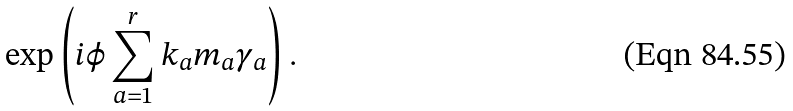Convert formula to latex. <formula><loc_0><loc_0><loc_500><loc_500>\exp \left ( i \varphi \sum _ { a = 1 } ^ { r } k _ { a } m _ { a } \gamma _ { a } \right ) .</formula> 